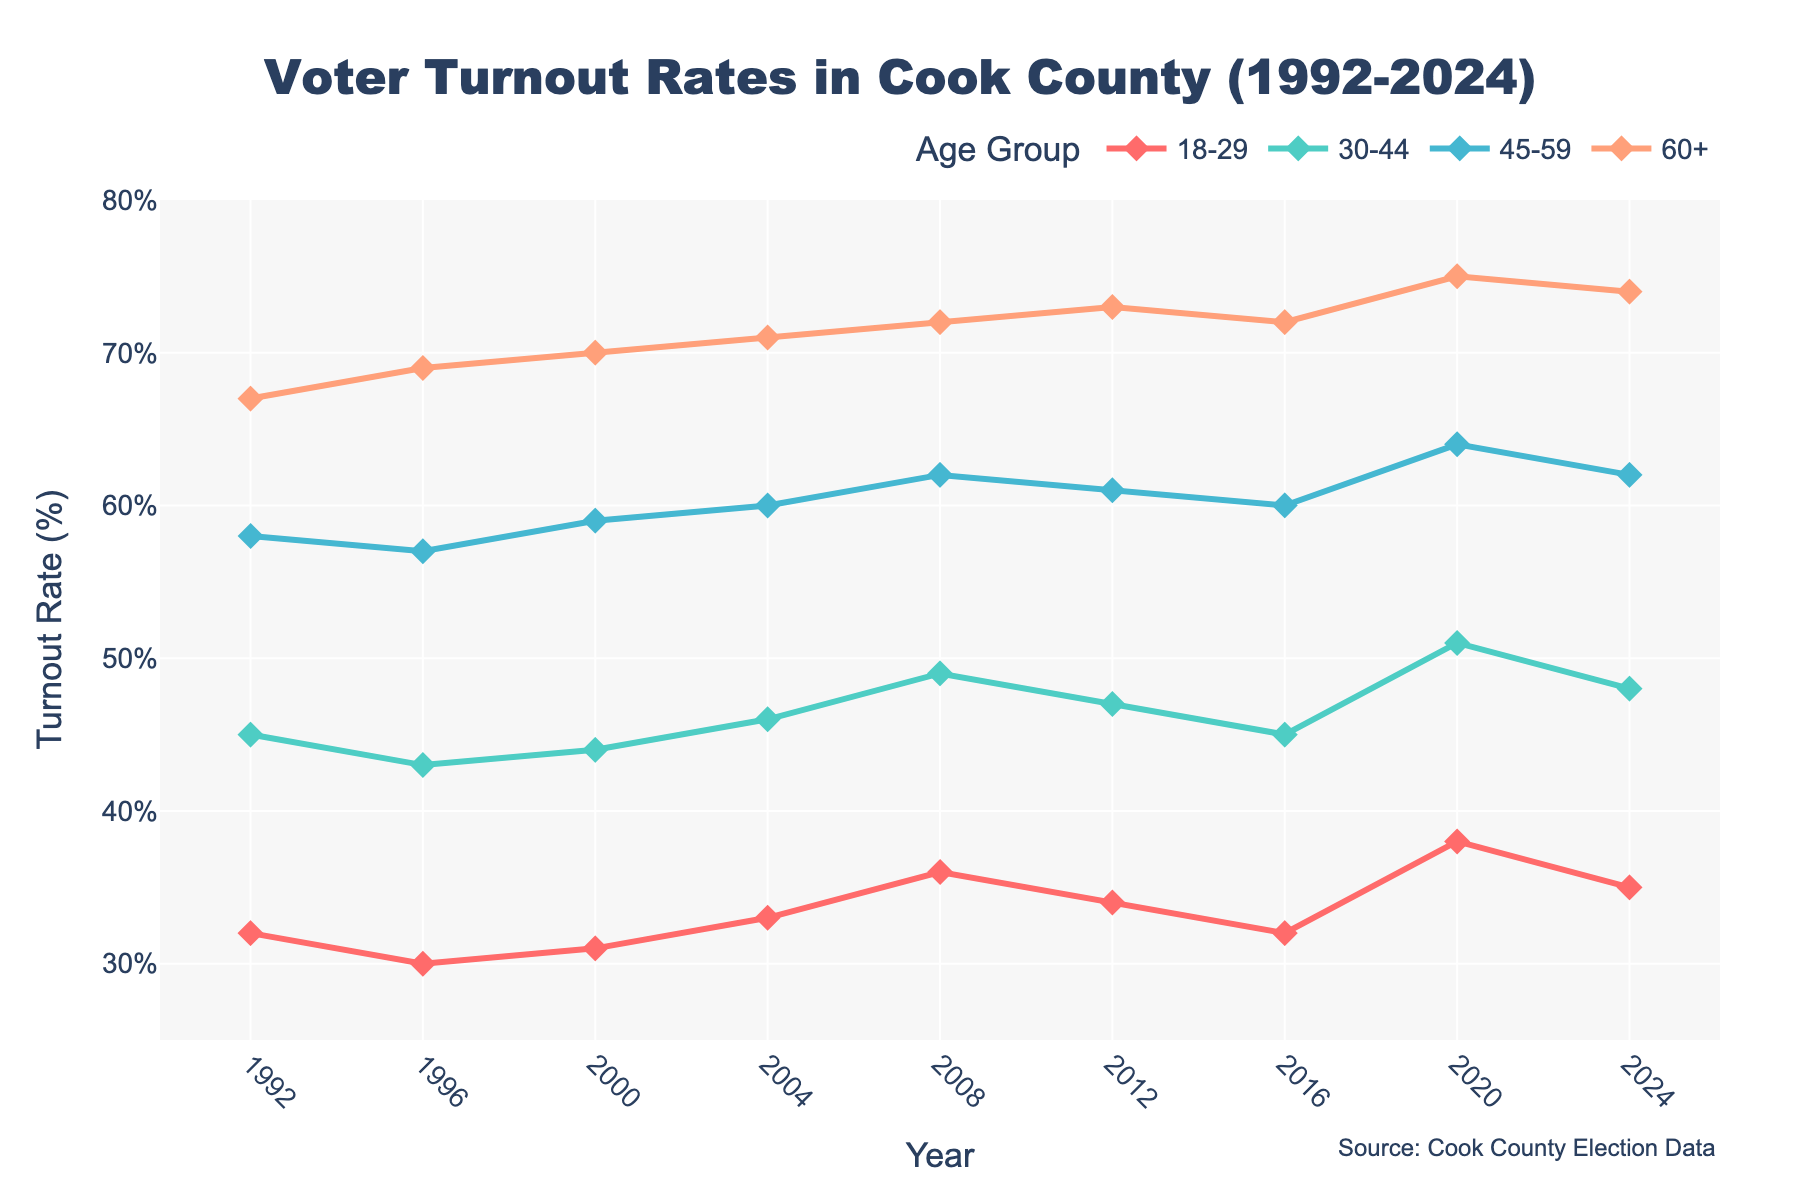Which age group had the highest voter turnout rate in 2020? In the chart, locate the year 2020 on the x-axis and check the turnout rates of all age groups. The age group 60+ has the highest turnout rate at 75%.
Answer: 60+ What is the difference in voter turnout rate between the 18-29 and 60+ age groups in 1996? In the chart, find the year 1996 along the x-axis, and then reference the turnout rates for the 18-29 age group (30%) and the 60+ age group (69%). The difference is 69% - 30% = 39%.
Answer: 39% How much did the voter turnout rate for the 45-59 age group change from 1992 to 2024? Check the voter turnout rates for the 45-59 age group in the years 1992 (58%) and 2024 (62%). The change is 62% - 58% = 4%.
Answer: 4% Which age group saw the largest increase in voter turnout rate from 1992 to 2020? For each age group, calculate the difference between their voter turnout rates in 1992 and 2020: 18-29 (38% - 32% = 6%), 30-44 (51% - 45% = 6%), 45-59 (64% - 58% = 6%), 60+ (75% - 67% = 8%). The 60+ age group had the largest increase of 8%.
Answer: 60+ On average, what was the voter turnout rate of the 30-44 age group across all the years presented? Sum the voter turnout rates for the 30-44 age group across all years (45 + 43 + 44 + 46 + 49 + 47 + 45 + 51 + 48 = 418), and then divide by the number of years (9). The average is 418 / 9 ≈ 46.44%.
Answer: 46.44% In which year did the 18-29 age group experience its highest voter turnout rate? Identify the highest data point for the 18-29 age group by checking across all the years. The highest rate, 38%, occurred in 2020.
Answer: 2020 How did the voter turnout rate for the 30-44 age group in 2008 compare to the 45-59 age group in 2012? Find the voter turnout rates for the 30-44 age group in 2008 (49%) and the 45-59 age group in 2012 (61%). 49% is less than 61%.
Answer: Less Which age group had the most consistent (least variable) voter turnout rates from 1992 to 2024? Check for the group with the smallest range of turnout rates. The 30-44 age group varies from 43% to 51%, a range of 8%. The other groups have ranges of 6-10.
Answer: 30-44 